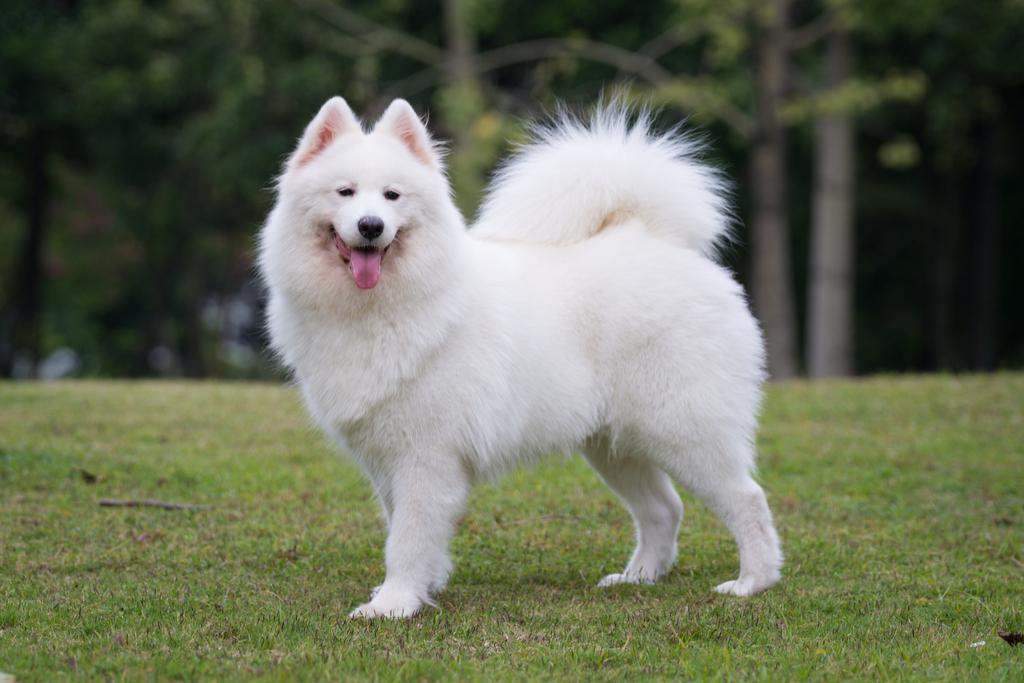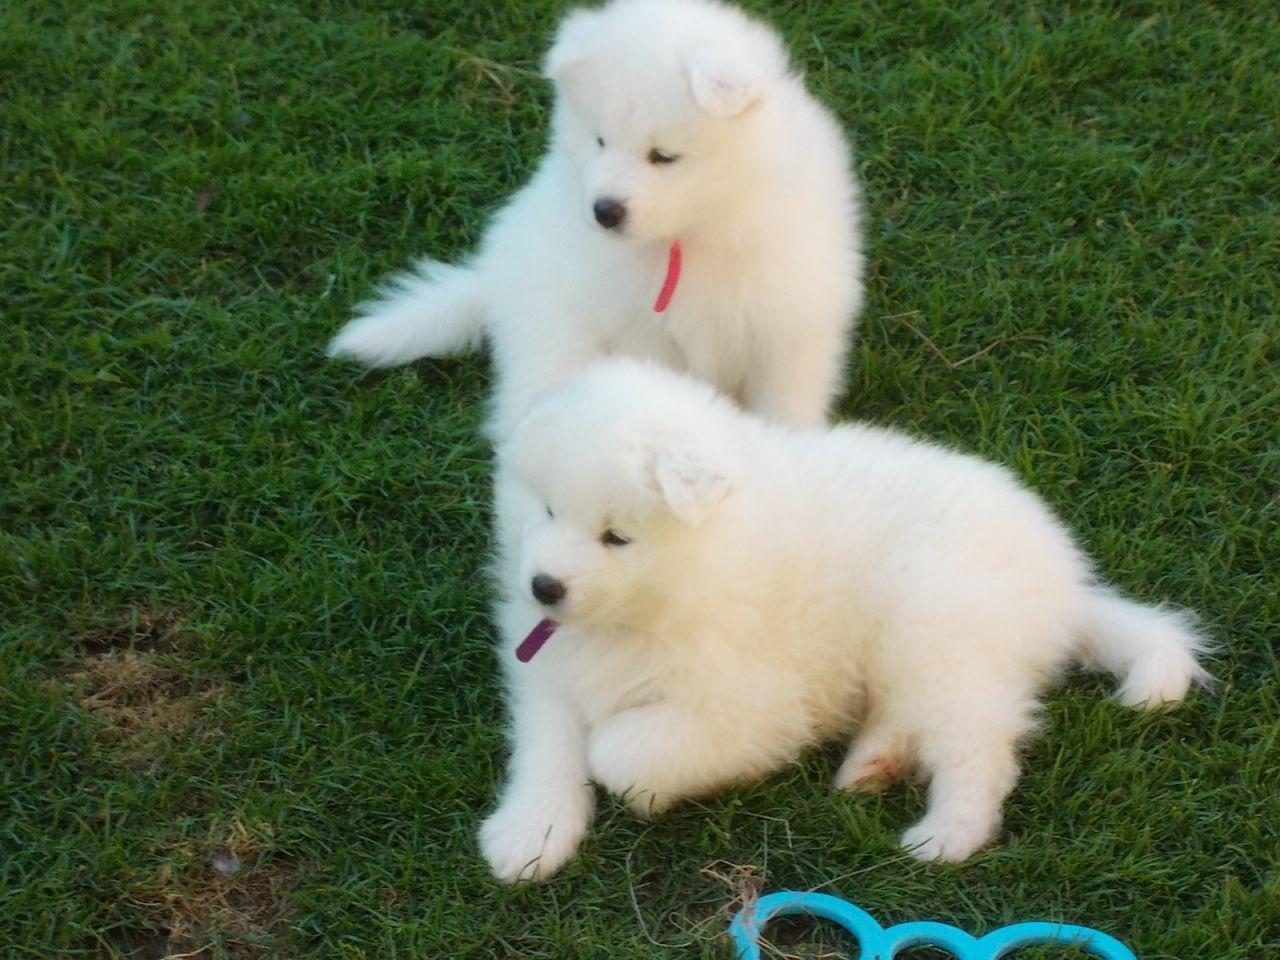The first image is the image on the left, the second image is the image on the right. Examine the images to the left and right. Is the description "Two dogs are in a grassy area in the image on the right." accurate? Answer yes or no. Yes. The first image is the image on the left, the second image is the image on the right. Given the left and right images, does the statement "there is a dog standing on the grass with a row of trees behind it" hold true? Answer yes or no. Yes. 